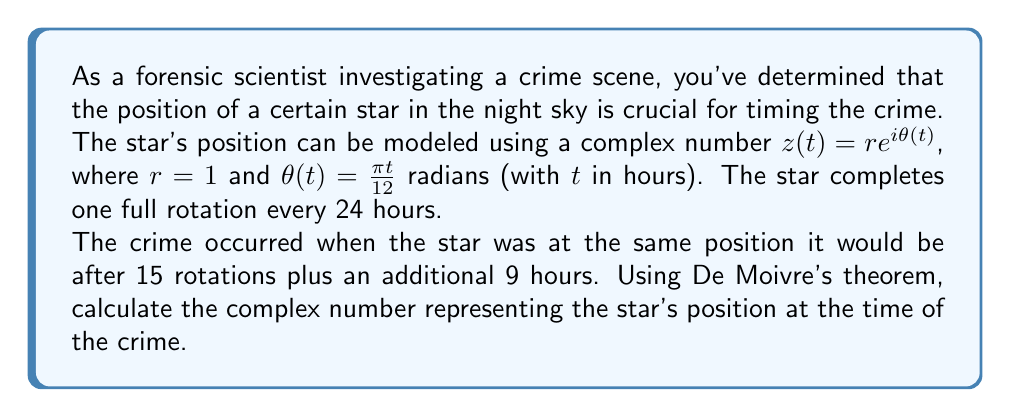Can you solve this math problem? Let's approach this step-by-step:

1) First, we need to determine the total time that has passed:
   15 full rotations (24 hours each) plus 9 hours
   $t = (15 \times 24) + 9 = 369$ hours

2) Now, we can calculate $\theta(t)$:
   $\theta(369) = \frac{\pi \times 369}{12} = \frac{369\pi}{12}$ radians

3) The complex number representing the star's position is given by:
   $z(t) = e^{i\theta(t)} = e^{i\frac{369\pi}{12}}$

4) We can simplify this using De Moivre's theorem. First, let's consider what $\frac{369\pi}{12}$ represents in terms of full rotations:

   $\frac{369\pi}{12} = 30.75\pi = 15(2\pi) + 0.75\pi$

   This means it's 15 full rotations plus $\frac{3\pi}{4}$ radians.

5) Since full rotations don't change the position, we can simplify to:
   $z(369) = e^{i\frac{3\pi}{4}}$

6) Using De Moivre's theorem, we know that:
   $e^{i\frac{3\pi}{4}} = \cos(\frac{3\pi}{4}) + i\sin(\frac{3\pi}{4})$

7) Calculating these values:
   $\cos(\frac{3\pi}{4}) = -\frac{\sqrt{2}}{2}$
   $\sin(\frac{3\pi}{4}) = \frac{\sqrt{2}}{2}$

Therefore, the final complex number is:
$z(369) = -\frac{\sqrt{2}}{2} + i\frac{\sqrt{2}}{2}$
Answer: $z(369) = -\frac{\sqrt{2}}{2} + i\frac{\sqrt{2}}{2}$ 